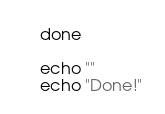Convert code to text. <code><loc_0><loc_0><loc_500><loc_500><_Bash_>done

echo ""
echo "Done!"
</code> 